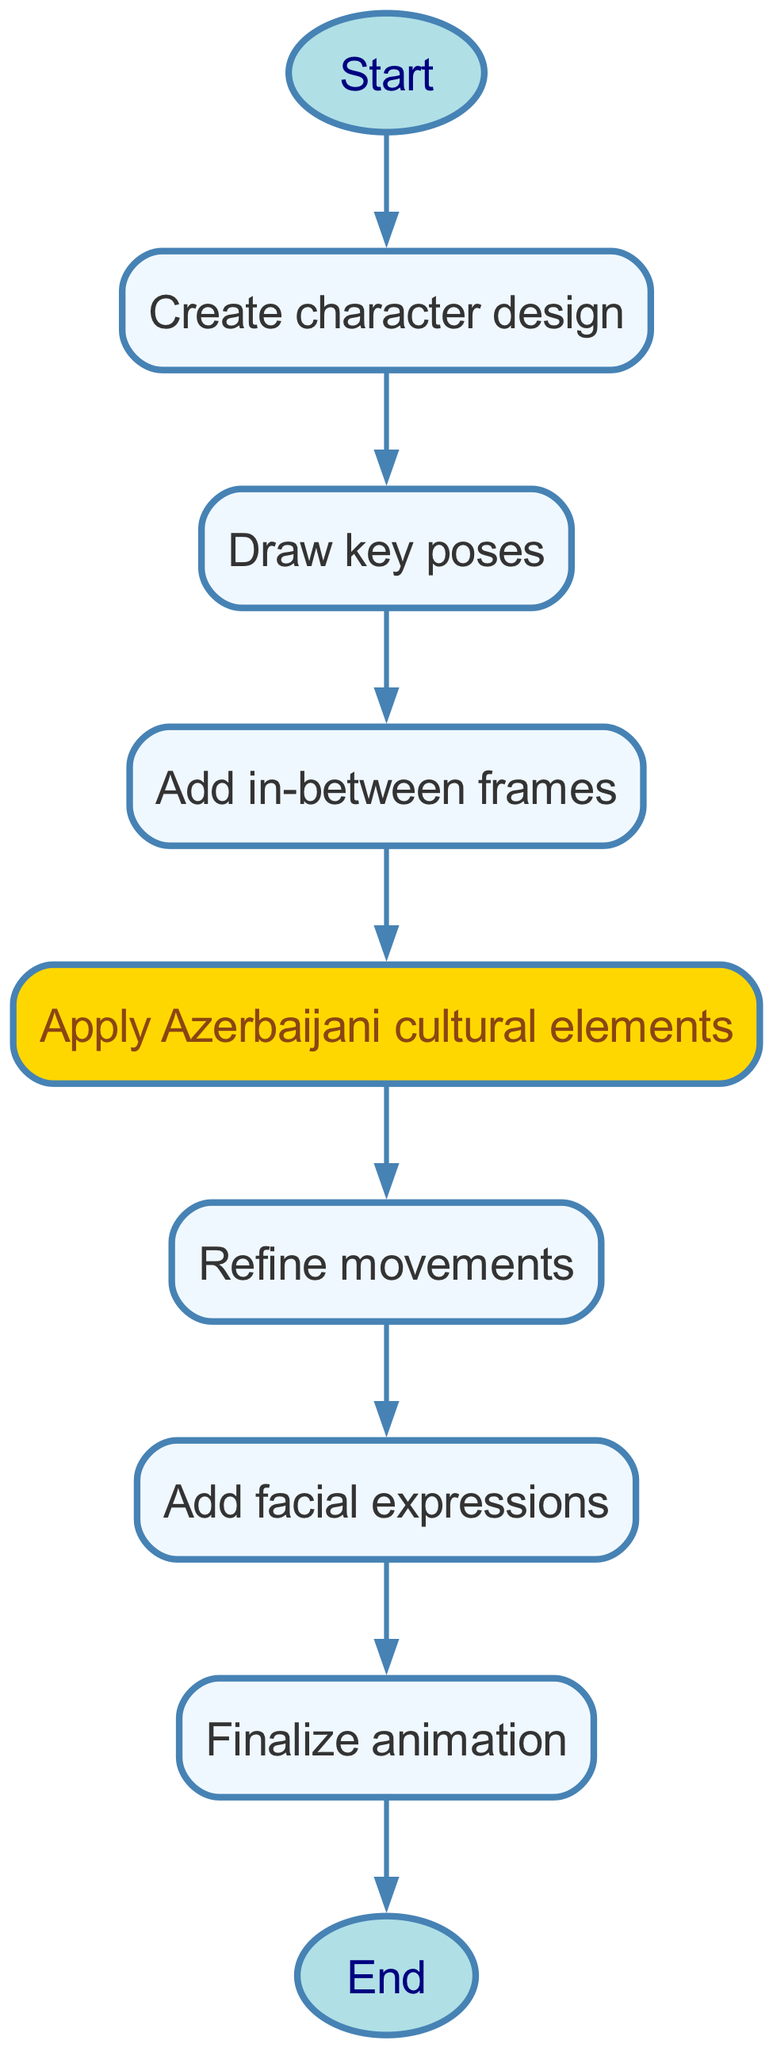What is the total number of nodes in the diagram? The diagram has a total of 9 nodes, which are represented by the different stages in the character animation process, ranging from "Start" to "End."
Answer: 9 Which node represents the step of adding cultural elements? The node labeled "Apply Azerbaijani cultural elements" corresponds to step 5 in the animation process, indicating where cultural aspects are integrated into the character design.
Answer: Apply Azerbaijani cultural elements How many edges are there connecting the nodes? There are 8 edges in the diagram connecting the 9 nodes, reflecting the sequential flow from the starting point to the end of the animation process.
Answer: 8 What is the first step in the character animation process? The first step, represented by node 2 immediately following “Start,” is creating the character design, which lays the foundation for the entire animation process.
Answer: Create character design What step directly follows refining movements? The node immediately after "Refine movements," which is node 6, leads to the step of "Add facial expressions," showing the ongoing development of the character's animation.
Answer: Add facial expressions What type of node is "Start"? The "Start" node, which is node 1 in the diagram, is represented as an oval shape, distinguishing it as a beginning point in the flowchart structure.
Answer: Oval Which node comes before the finalization of the animation? The node that precedes "Finalize animation," which is node 8, is "Add facial expressions," indicating the last detail before the completed animation is finalized.
Answer: Add facial expressions What color is the node for adding cultural elements? The node labeled "Apply Azerbaijani cultural elements" is highlighted in a yellowish color (FFD700), signifying its special importance within the overall animation process.
Answer: Yellow How does the process flow from drawing key poses to adding in-between frames? The flowchart illustrates a direct connection from "Draw key poses" (node 3) to "Add in-between frames" (node 4), indicating that in-between frames are drawn after the key poses are established.
Answer: Direct connection 